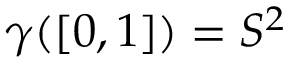Convert formula to latex. <formula><loc_0><loc_0><loc_500><loc_500>\gamma ( [ 0 , 1 ] ) = S ^ { 2 }</formula> 